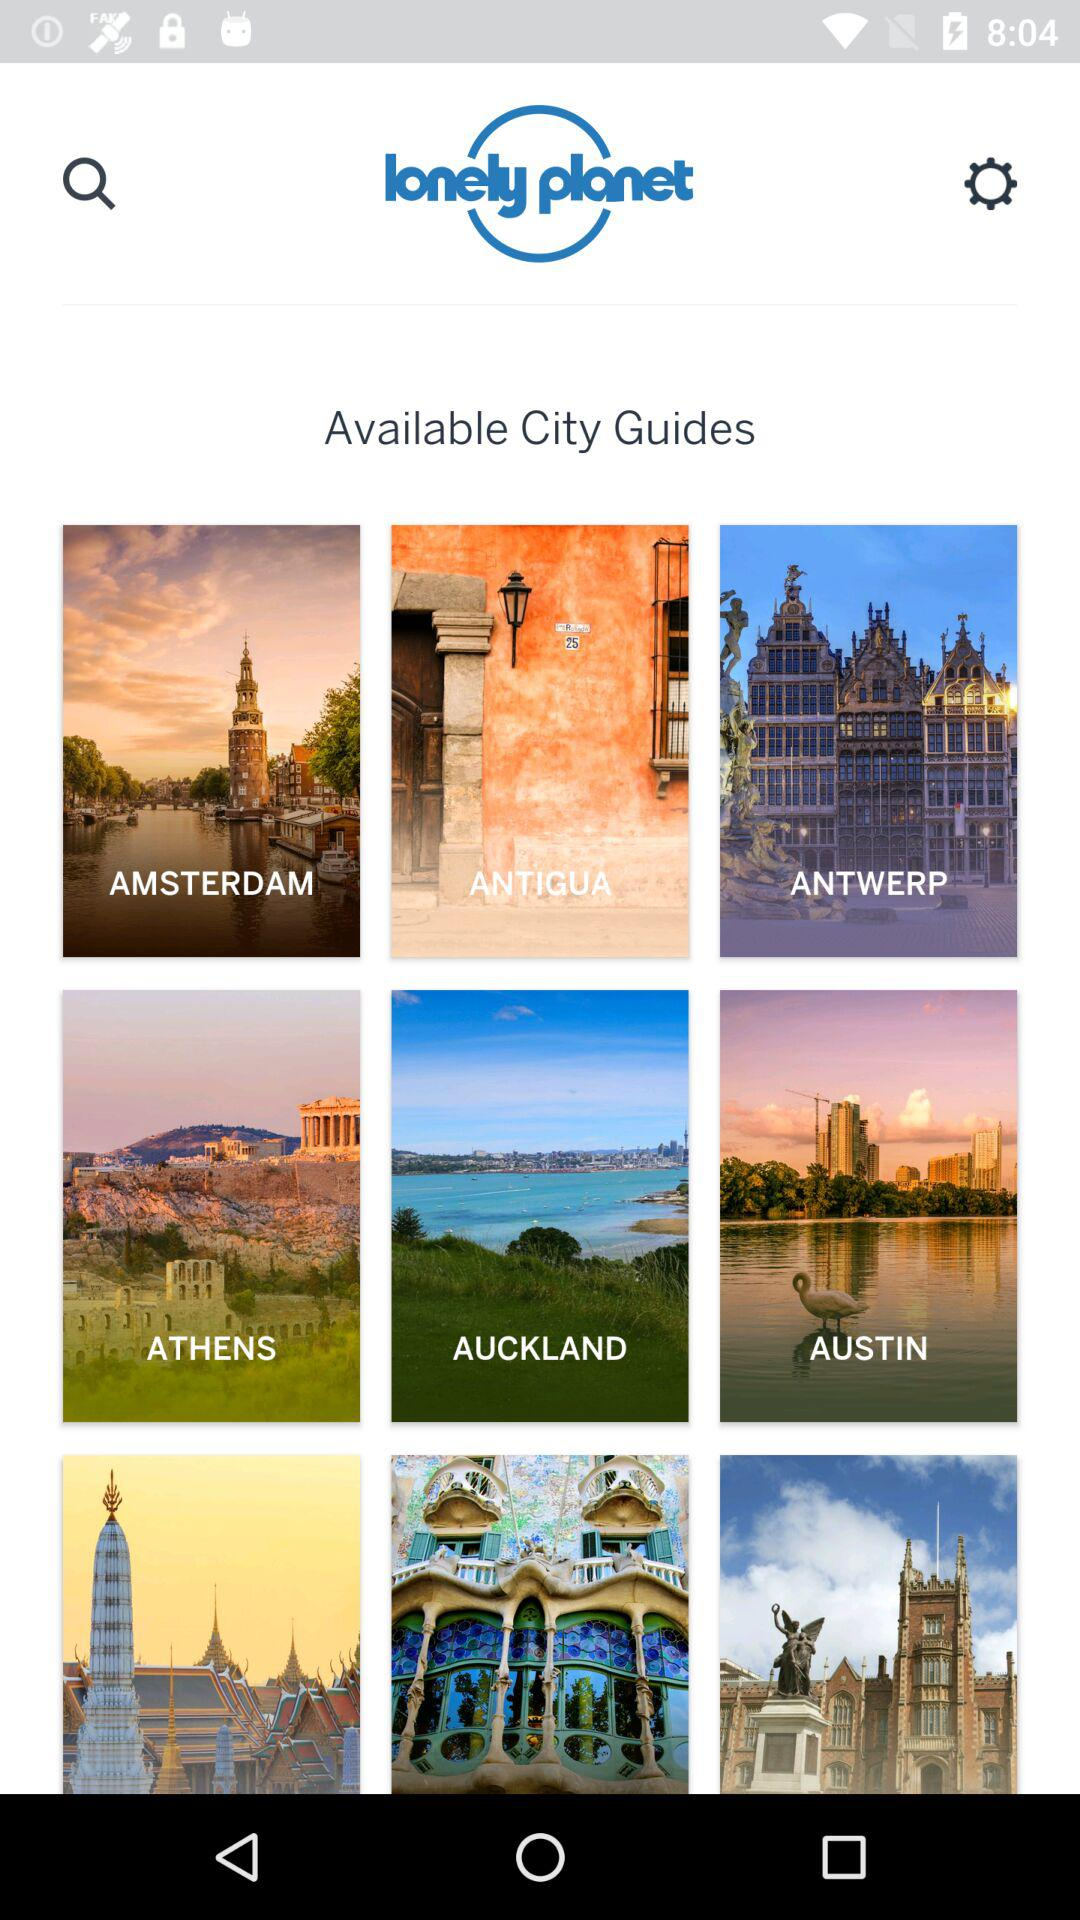What is the name of the application? The name of the application is "Lonely Planet UK Magazine - Travel Inspiration". 